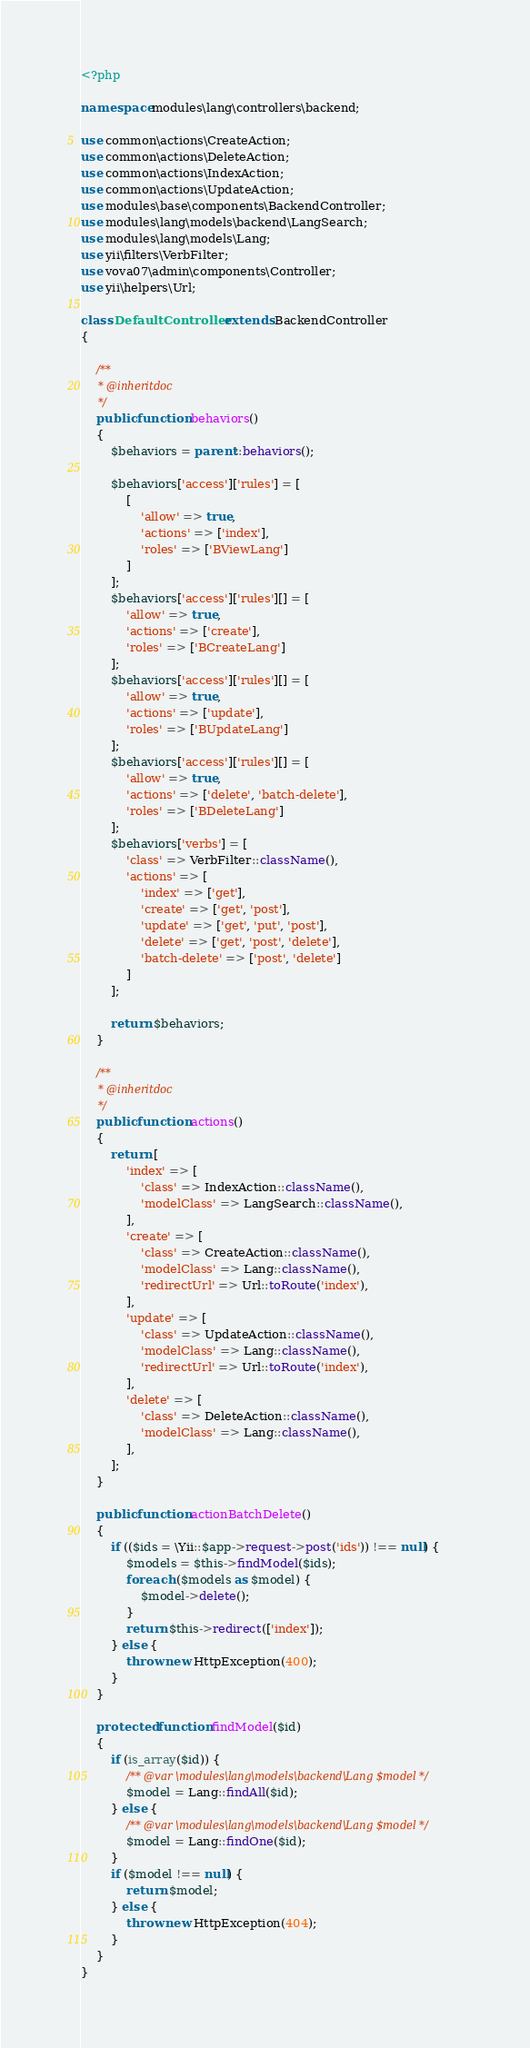Convert code to text. <code><loc_0><loc_0><loc_500><loc_500><_PHP_><?php

namespace modules\lang\controllers\backend;

use common\actions\CreateAction;
use common\actions\DeleteAction;
use common\actions\IndexAction;
use common\actions\UpdateAction;
use modules\base\components\BackendController;
use modules\lang\models\backend\LangSearch;
use modules\lang\models\Lang;
use yii\filters\VerbFilter;
use vova07\admin\components\Controller;
use yii\helpers\Url;

class DefaultController extends BackendController
{

    /**
     * @inheritdoc
     */
    public function behaviors()
    {
        $behaviors = parent::behaviors();

        $behaviors['access']['rules'] = [
            [
                'allow' => true,
                'actions' => ['index'],
                'roles' => ['BViewLang']
            ]
        ];
        $behaviors['access']['rules'][] = [
            'allow' => true,
            'actions' => ['create'],
            'roles' => ['BCreateLang']
        ];
        $behaviors['access']['rules'][] = [
            'allow' => true,
            'actions' => ['update'],
            'roles' => ['BUpdateLang']
        ];
        $behaviors['access']['rules'][] = [
            'allow' => true,
            'actions' => ['delete', 'batch-delete'],
            'roles' => ['BDeleteLang']
        ];
        $behaviors['verbs'] = [
            'class' => VerbFilter::className(),
            'actions' => [
                'index' => ['get'],
                'create' => ['get', 'post'],
                'update' => ['get', 'put', 'post'],
                'delete' => ['get', 'post', 'delete'],
                'batch-delete' => ['post', 'delete']
            ]
        ];

        return $behaviors;
    }

    /**
     * @inheritdoc
     */
    public function actions()
    {
        return [
            'index' => [
                'class' => IndexAction::className(),
                'modelClass' => LangSearch::className(),
            ],
            'create' => [
                'class' => CreateAction::className(),
                'modelClass' => Lang::className(),
                'redirectUrl' => Url::toRoute('index'),
            ],
            'update' => [
                'class' => UpdateAction::className(),
                'modelClass' => Lang::className(),
                'redirectUrl' => Url::toRoute('index'),
            ],
            'delete' => [
                'class' => DeleteAction::className(),
                'modelClass' => Lang::className(),
            ],
        ];
    }

    public function actionBatchDelete()
    {
        if (($ids = \Yii::$app->request->post('ids')) !== null) {
            $models = $this->findModel($ids);
            foreach ($models as $model) {
                $model->delete();
            }
            return $this->redirect(['index']);
        } else {
            throw new HttpException(400);
        }
    }

    protected function findModel($id)
    {
        if (is_array($id)) {
            /** @var \modules\lang\models\backend\Lang $model */
            $model = Lang::findAll($id);
        } else {
            /** @var \modules\lang\models\backend\Lang $model */
            $model = Lang::findOne($id);
        }
        if ($model !== null) {
            return $model;
        } else {
            throw new HttpException(404);
        }
    }
}
</code> 